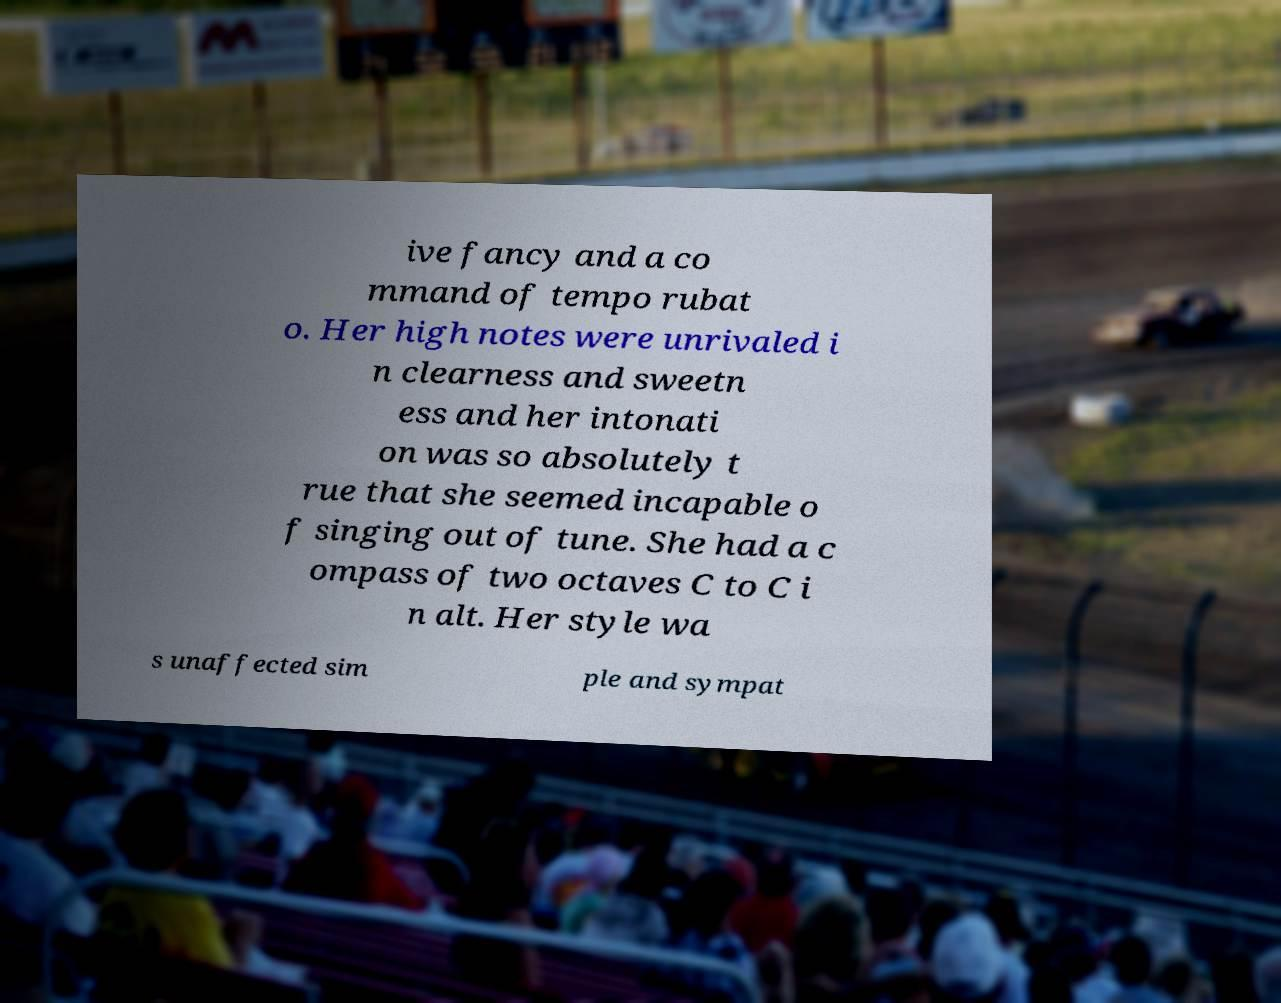I need the written content from this picture converted into text. Can you do that? ive fancy and a co mmand of tempo rubat o. Her high notes were unrivaled i n clearness and sweetn ess and her intonati on was so absolutely t rue that she seemed incapable o f singing out of tune. She had a c ompass of two octaves C to C i n alt. Her style wa s unaffected sim ple and sympat 